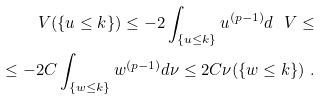<formula> <loc_0><loc_0><loc_500><loc_500>\ V ( \{ u \leq k \} ) \leq - 2 \int _ { \{ u \leq k \} } u ^ { ( p - 1 ) } d \ V \leq \\ \leq - 2 C \int _ { \{ w \leq k \} } w ^ { ( p - 1 ) } d \nu \leq 2 C \nu ( \{ w \leq k \} ) \ .</formula> 